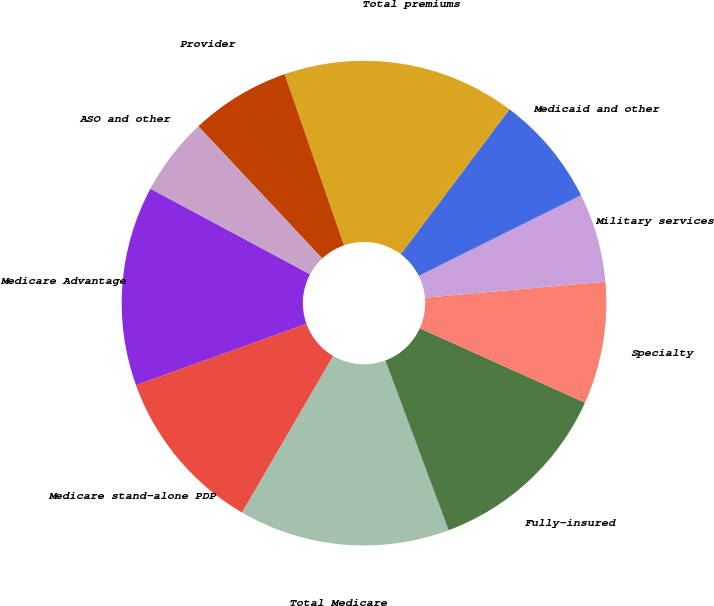<chart> <loc_0><loc_0><loc_500><loc_500><pie_chart><fcel>Medicare Advantage<fcel>Medicare stand-alone PDP<fcel>Total Medicare<fcel>Fully-insured<fcel>Specialty<fcel>Military services<fcel>Medicaid and other<fcel>Total premiums<fcel>Provider<fcel>ASO and other<nl><fcel>13.33%<fcel>11.11%<fcel>14.07%<fcel>12.59%<fcel>8.15%<fcel>5.93%<fcel>7.41%<fcel>15.56%<fcel>6.67%<fcel>5.19%<nl></chart> 